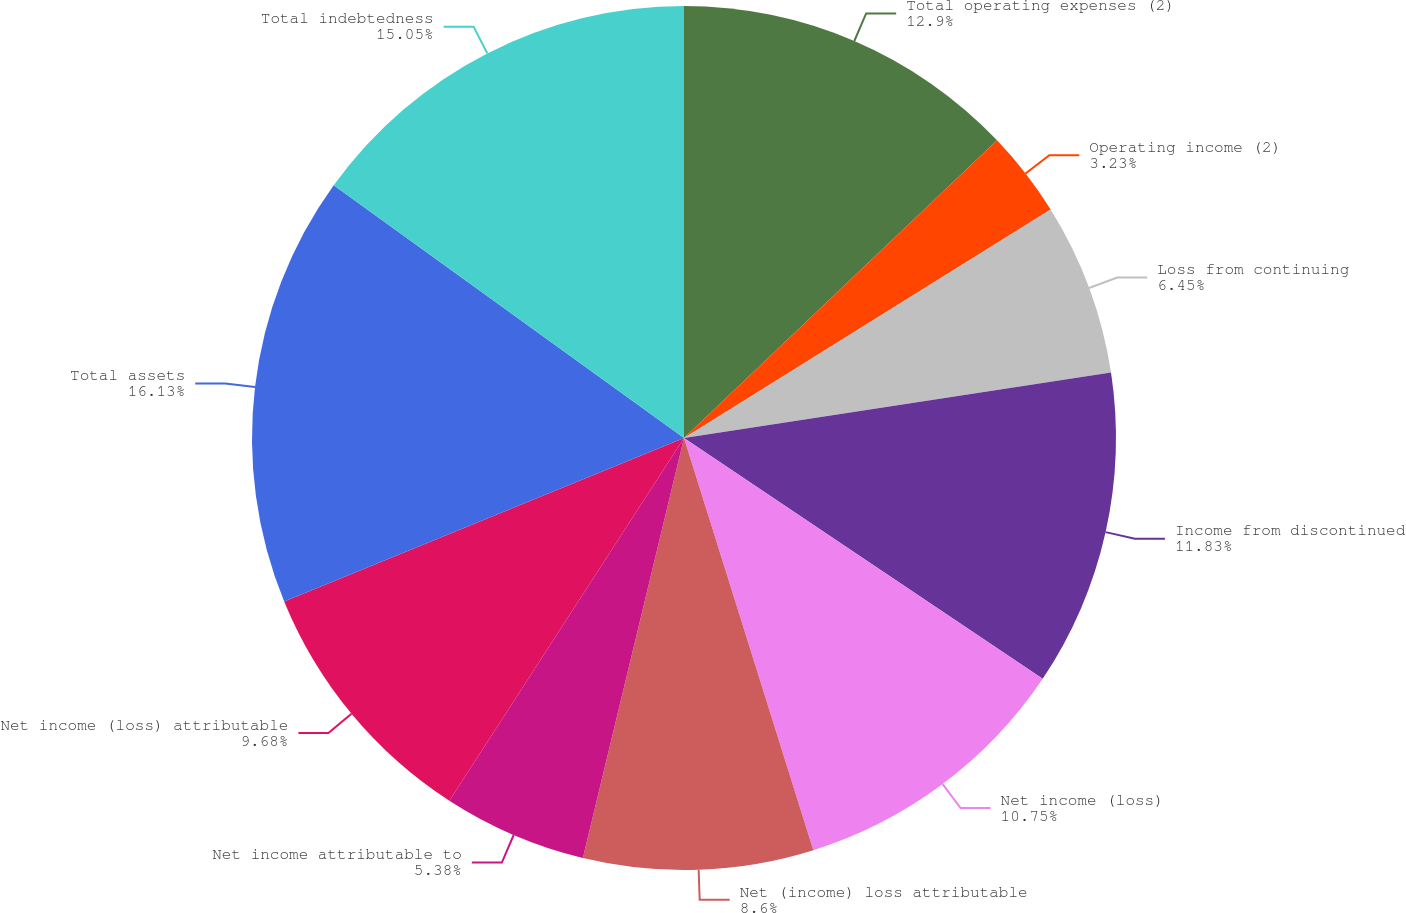Convert chart to OTSL. <chart><loc_0><loc_0><loc_500><loc_500><pie_chart><fcel>Total operating expenses (2)<fcel>Operating income (2)<fcel>Loss from continuing<fcel>Income from discontinued<fcel>Net income (loss)<fcel>Net (income) loss attributable<fcel>Net income attributable to<fcel>Net income (loss) attributable<fcel>Total assets<fcel>Total indebtedness<nl><fcel>12.9%<fcel>3.23%<fcel>6.45%<fcel>11.83%<fcel>10.75%<fcel>8.6%<fcel>5.38%<fcel>9.68%<fcel>16.13%<fcel>15.05%<nl></chart> 